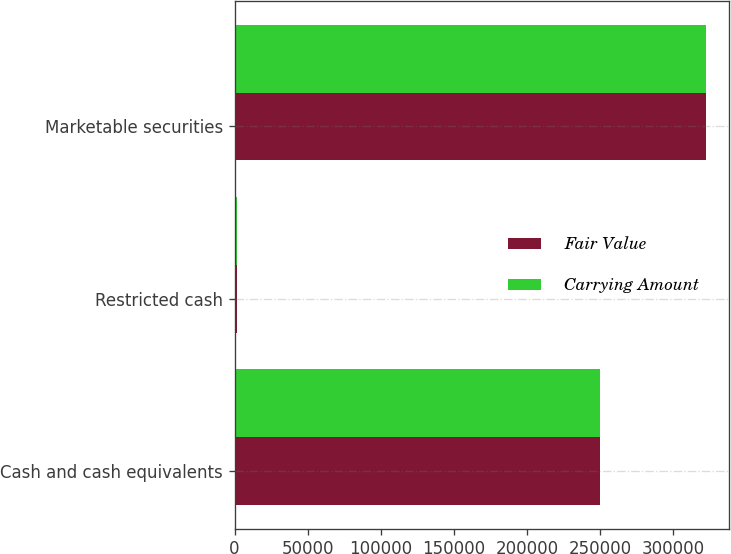<chart> <loc_0><loc_0><loc_500><loc_500><stacked_bar_chart><ecel><fcel>Cash and cash equivalents<fcel>Restricted cash<fcel>Marketable securities<nl><fcel>Fair Value<fcel>249909<fcel>1457<fcel>322215<nl><fcel>Carrying Amount<fcel>249909<fcel>1457<fcel>322215<nl></chart> 